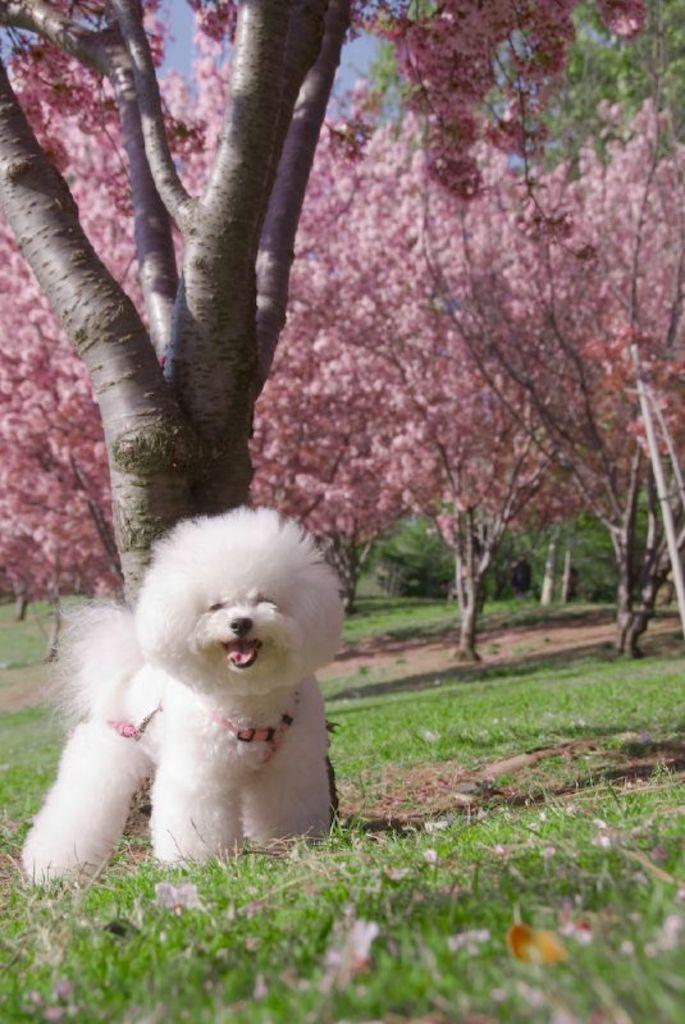What type of animal is in the image? There is a puppy in the image. Where is the puppy located? The puppy is on the ground. What is the puppy wearing? The puppy is wearing a belt. What can be seen in the background of the image? There are blossom trees in the background of the image. What type of breakfast is the puppy eating in the image? There is no breakfast present in the image; it features a puppy wearing a belt on the ground with blossom trees in the background. 